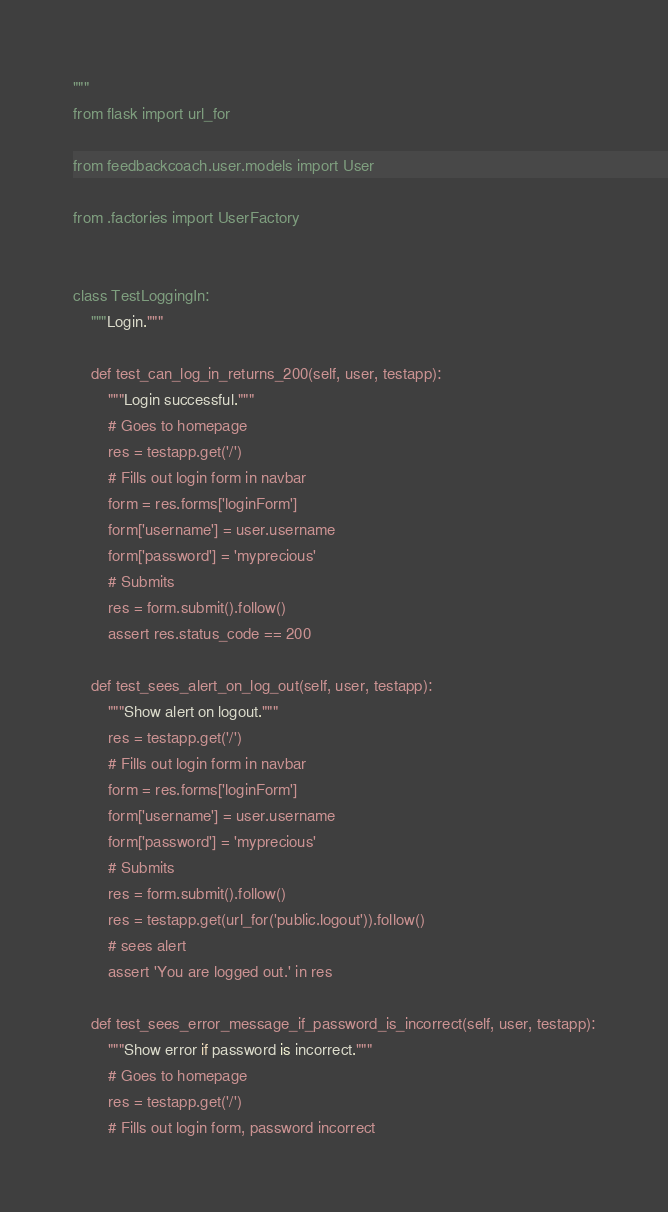Convert code to text. <code><loc_0><loc_0><loc_500><loc_500><_Python_>"""
from flask import url_for

from feedbackcoach.user.models import User

from .factories import UserFactory


class TestLoggingIn:
    """Login."""

    def test_can_log_in_returns_200(self, user, testapp):
        """Login successful."""
        # Goes to homepage
        res = testapp.get('/')
        # Fills out login form in navbar
        form = res.forms['loginForm']
        form['username'] = user.username
        form['password'] = 'myprecious'
        # Submits
        res = form.submit().follow()
        assert res.status_code == 200

    def test_sees_alert_on_log_out(self, user, testapp):
        """Show alert on logout."""
        res = testapp.get('/')
        # Fills out login form in navbar
        form = res.forms['loginForm']
        form['username'] = user.username
        form['password'] = 'myprecious'
        # Submits
        res = form.submit().follow()
        res = testapp.get(url_for('public.logout')).follow()
        # sees alert
        assert 'You are logged out.' in res

    def test_sees_error_message_if_password_is_incorrect(self, user, testapp):
        """Show error if password is incorrect."""
        # Goes to homepage
        res = testapp.get('/')
        # Fills out login form, password incorrect</code> 